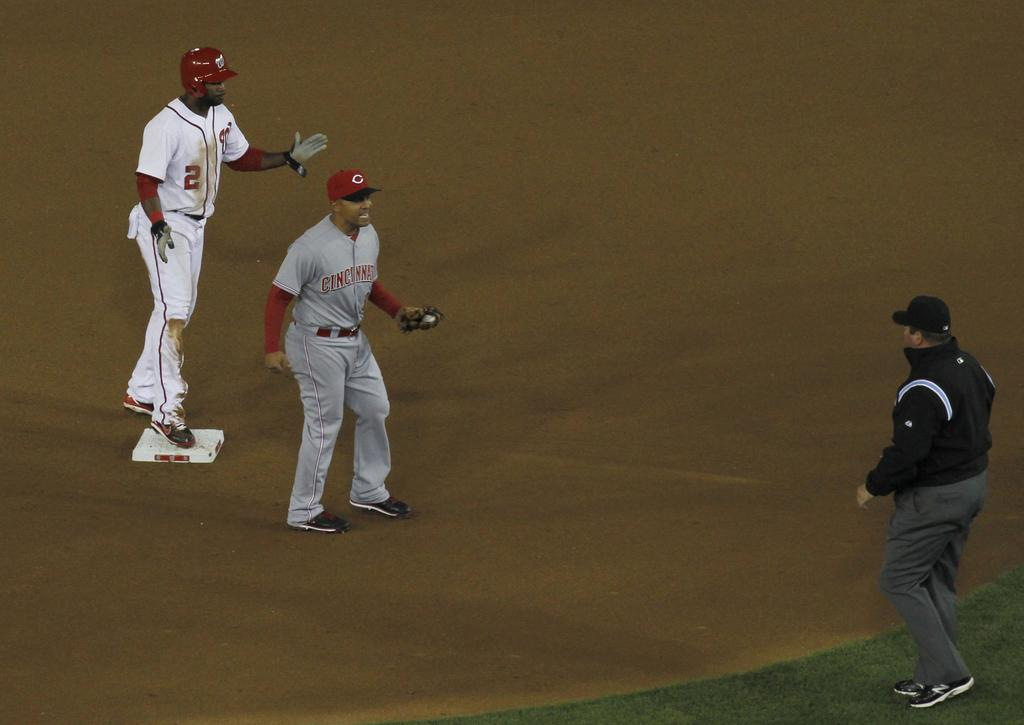How many people are on the playground in the image? There are two players on the playground in the image. Can you describe the appearance of one of the individuals? There is a man wearing a black color cap in the image. What is the man standing on? The man is standing on the grass in the image. What type of skirt is the man wearing in the image? The man in the image is not wearing a skirt; he is wearing a cap and standing on the grass. How many pigs can be seen interacting with the players on the playground? There are no pigs present in the image; it features two players and a man wearing a cap. 